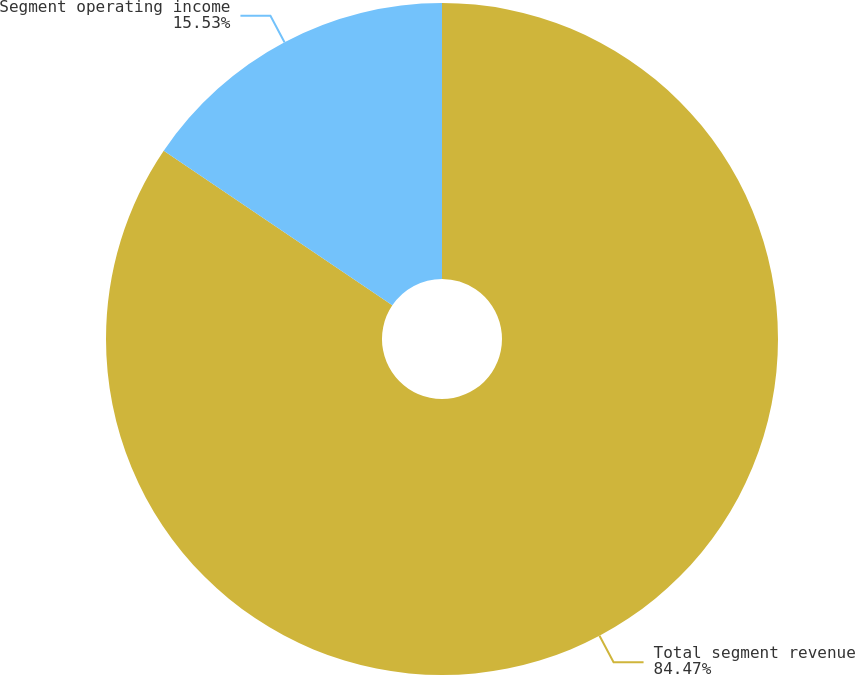Convert chart to OTSL. <chart><loc_0><loc_0><loc_500><loc_500><pie_chart><fcel>Total segment revenue<fcel>Segment operating income<nl><fcel>84.47%<fcel>15.53%<nl></chart> 